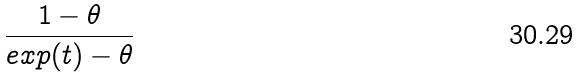<formula> <loc_0><loc_0><loc_500><loc_500>\frac { 1 - \theta } { e x p ( t ) - \theta }</formula> 